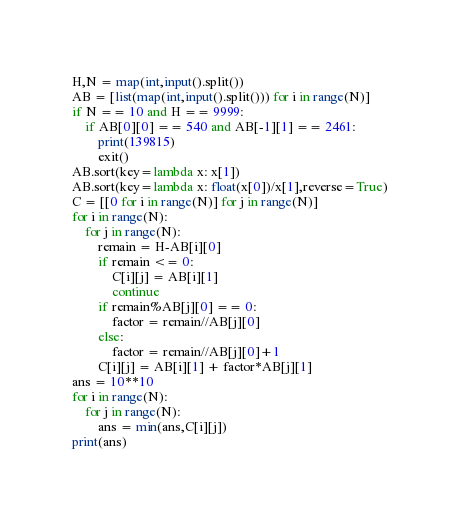Convert code to text. <code><loc_0><loc_0><loc_500><loc_500><_Python_>H,N = map(int,input().split())
AB = [list(map(int,input().split())) for i in range(N)]
if N == 10 and H == 9999:
    if AB[0][0] == 540 and AB[-1][1] == 2461:
        print(139815)
        exit()
AB.sort(key=lambda x: x[1])
AB.sort(key=lambda x: float(x[0])/x[1],reverse=True)
C = [[0 for i in range(N)] for j in range(N)]
for i in range(N):
    for j in range(N):
        remain = H-AB[i][0]
        if remain <= 0:
            C[i][j] = AB[i][1]
            continue
        if remain%AB[j][0] == 0:
            factor = remain//AB[j][0]
        else:
            factor = remain//AB[j][0]+1
        C[i][j] = AB[i][1] + factor*AB[j][1]
ans = 10**10
for i in range(N):
    for j in range(N):
        ans = min(ans,C[i][j])
print(ans)</code> 